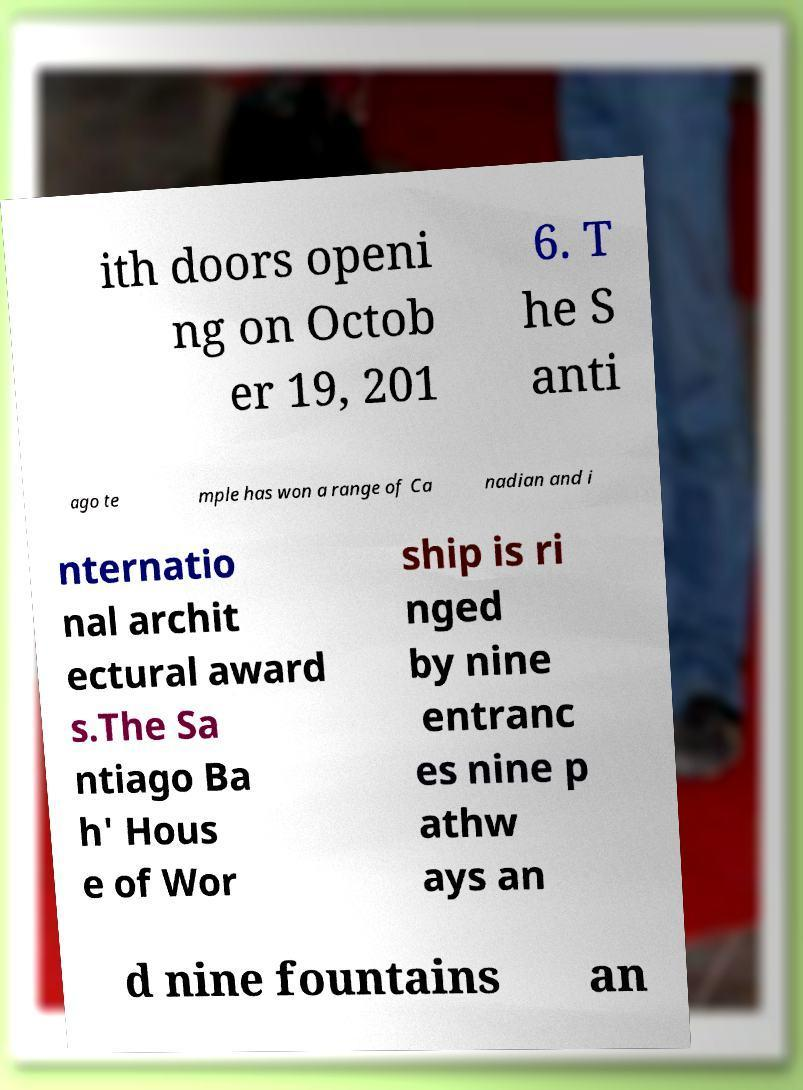There's text embedded in this image that I need extracted. Can you transcribe it verbatim? ith doors openi ng on Octob er 19, 201 6. T he S anti ago te mple has won a range of Ca nadian and i nternatio nal archit ectural award s.The Sa ntiago Ba h' Hous e of Wor ship is ri nged by nine entranc es nine p athw ays an d nine fountains an 